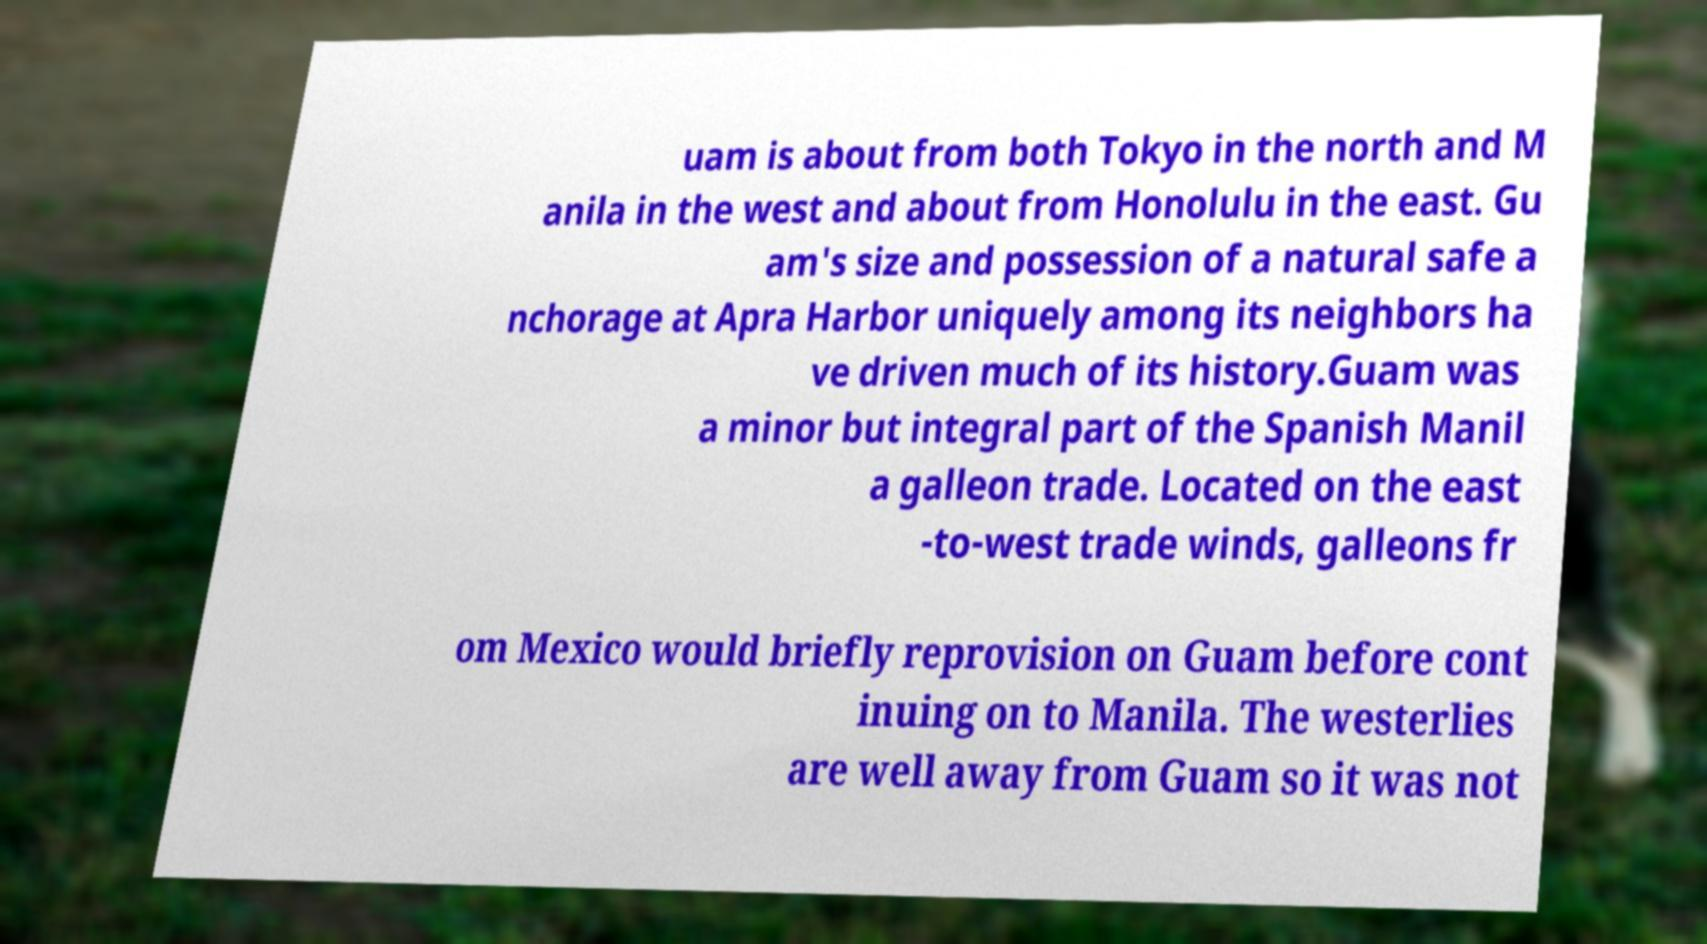Could you extract and type out the text from this image? uam is about from both Tokyo in the north and M anila in the west and about from Honolulu in the east. Gu am's size and possession of a natural safe a nchorage at Apra Harbor uniquely among its neighbors ha ve driven much of its history.Guam was a minor but integral part of the Spanish Manil a galleon trade. Located on the east -to-west trade winds, galleons fr om Mexico would briefly reprovision on Guam before cont inuing on to Manila. The westerlies are well away from Guam so it was not 